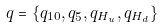<formula> <loc_0><loc_0><loc_500><loc_500>q = \{ q _ { 1 0 } , q _ { \bar { 5 } } , q _ { H _ { u } } , q _ { H _ { d } } \}</formula> 